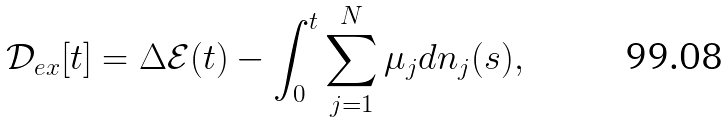<formula> <loc_0><loc_0><loc_500><loc_500>\mathcal { D } _ { e x } [ t ] = \Delta \mathcal { E } ( t ) - \int _ { 0 } ^ { t } \sum _ { j = 1 } ^ { N } \mu _ { j } d n _ { j } ( s ) ,</formula> 